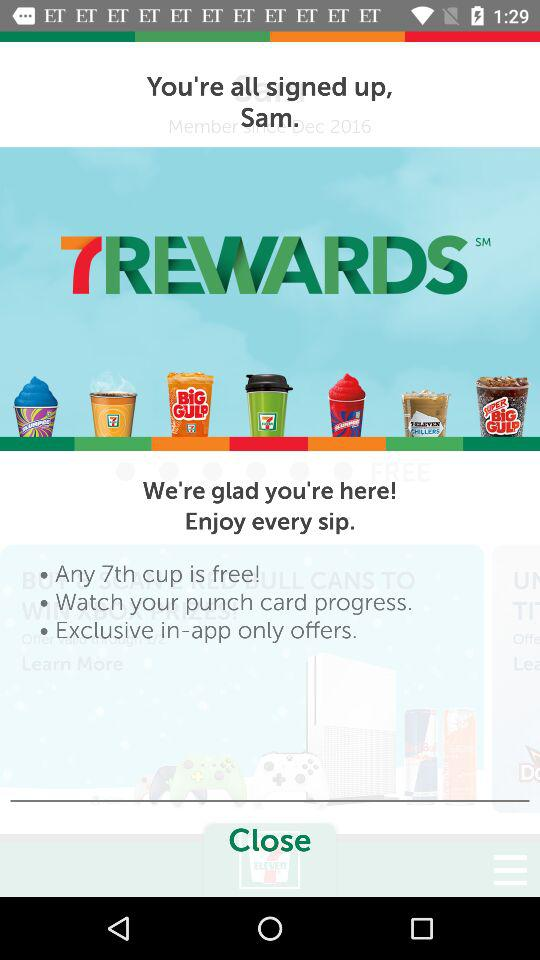How many cups of coffee do you need to get a free 7th cup?
Answer the question using a single word or phrase. 7 